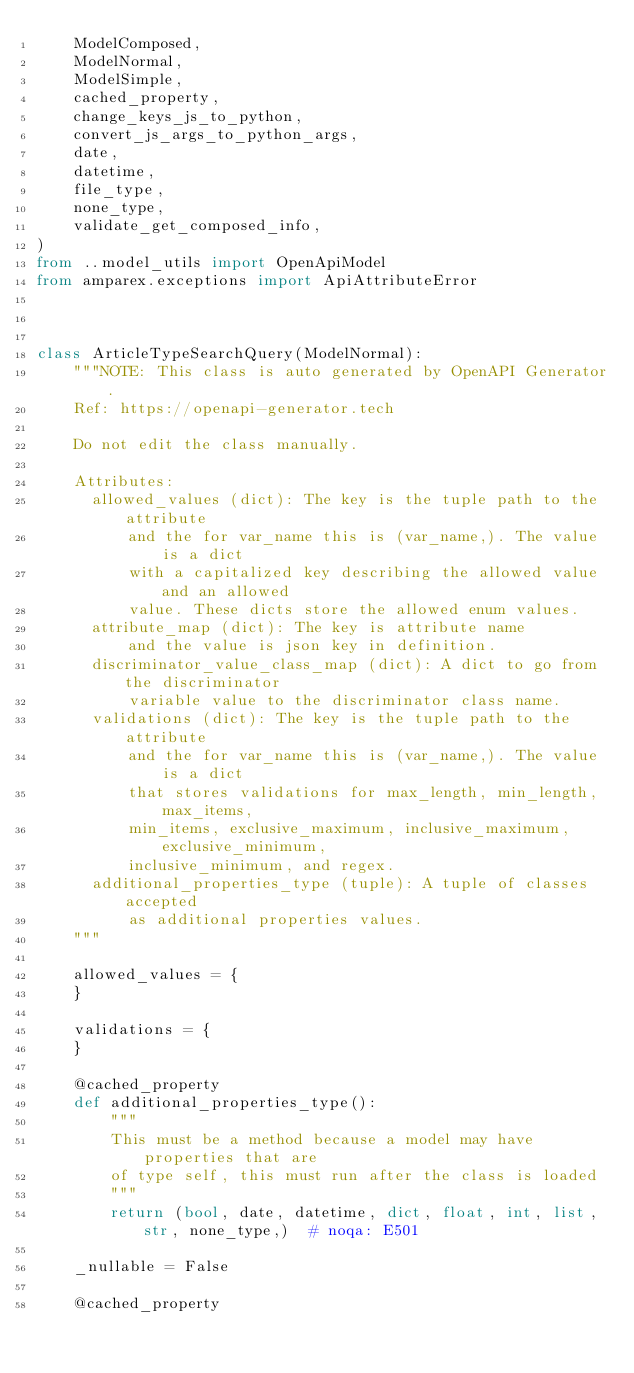Convert code to text. <code><loc_0><loc_0><loc_500><loc_500><_Python_>    ModelComposed,
    ModelNormal,
    ModelSimple,
    cached_property,
    change_keys_js_to_python,
    convert_js_args_to_python_args,
    date,
    datetime,
    file_type,
    none_type,
    validate_get_composed_info,
)
from ..model_utils import OpenApiModel
from amparex.exceptions import ApiAttributeError



class ArticleTypeSearchQuery(ModelNormal):
    """NOTE: This class is auto generated by OpenAPI Generator.
    Ref: https://openapi-generator.tech

    Do not edit the class manually.

    Attributes:
      allowed_values (dict): The key is the tuple path to the attribute
          and the for var_name this is (var_name,). The value is a dict
          with a capitalized key describing the allowed value and an allowed
          value. These dicts store the allowed enum values.
      attribute_map (dict): The key is attribute name
          and the value is json key in definition.
      discriminator_value_class_map (dict): A dict to go from the discriminator
          variable value to the discriminator class name.
      validations (dict): The key is the tuple path to the attribute
          and the for var_name this is (var_name,). The value is a dict
          that stores validations for max_length, min_length, max_items,
          min_items, exclusive_maximum, inclusive_maximum, exclusive_minimum,
          inclusive_minimum, and regex.
      additional_properties_type (tuple): A tuple of classes accepted
          as additional properties values.
    """

    allowed_values = {
    }

    validations = {
    }

    @cached_property
    def additional_properties_type():
        """
        This must be a method because a model may have properties that are
        of type self, this must run after the class is loaded
        """
        return (bool, date, datetime, dict, float, int, list, str, none_type,)  # noqa: E501

    _nullable = False

    @cached_property</code> 